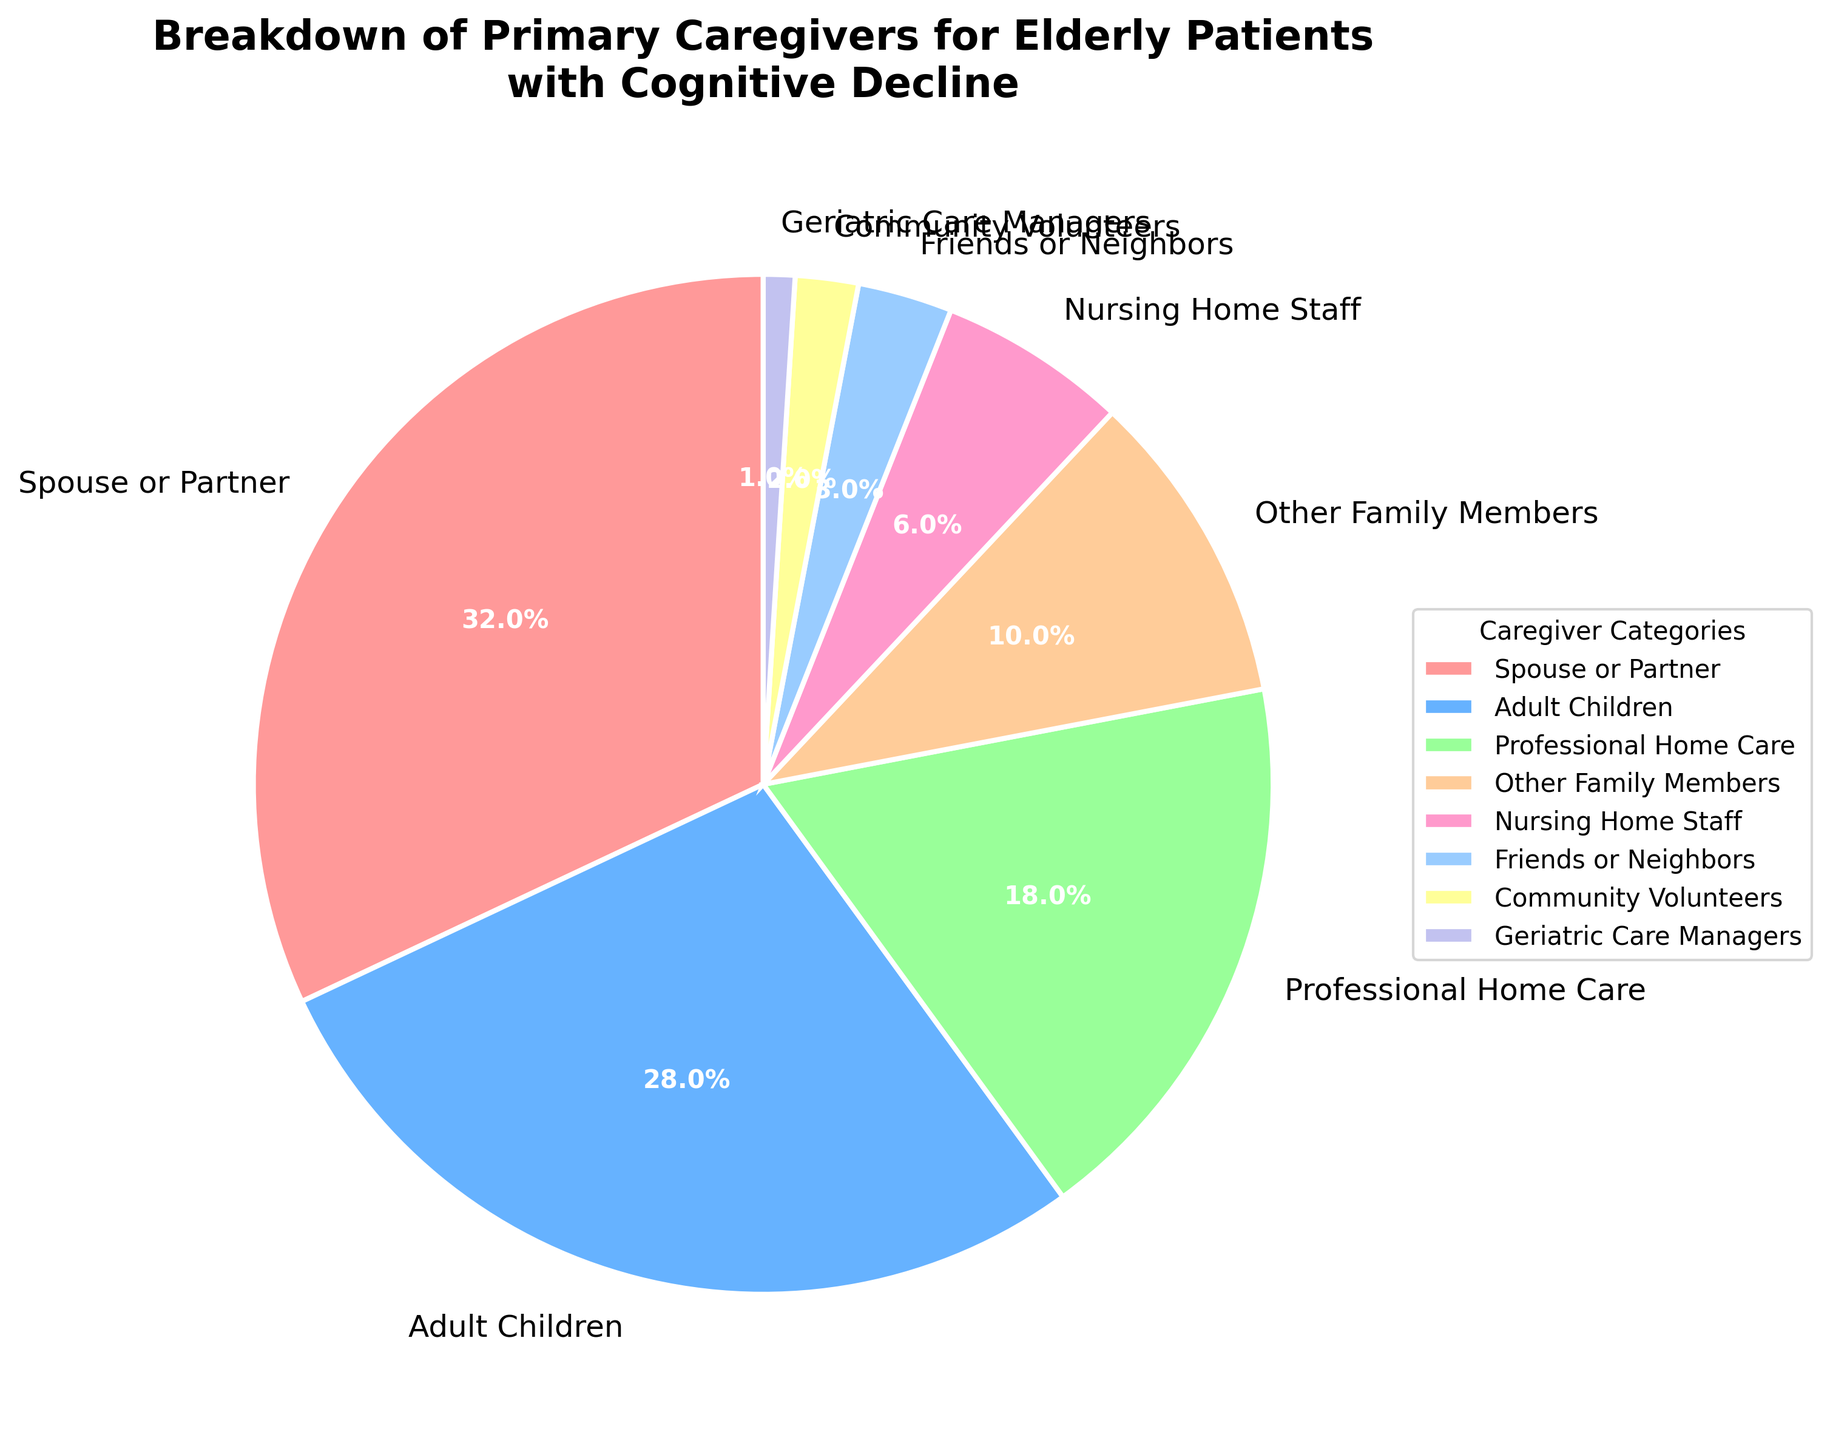What is the category with the highest percentage of primary caregivers? The pie chart shows various categories with their respective percentages. The slice representing "Spouse or Partner" is the largest, with a percentage of 32%.
Answer: Spouse or Partner Which two categories together account for more than half of the primary caregivers? By adding the percentages of the first two highest categories: Spouse or Partner (32%) and Adult Children (28%), the total is 32% + 28% = 60%, which is more than half.
Answer: Spouse or Partner and Adult Children How many categories make up less than 10% of the primary caregivers each? The pie chart shows that categories with less than 10% are Professional Home Care (18%), Other Family Members (10%), Nursing Home Staff (6%), Friends or Neighbors (3%), Community Volunteers (2%), and Geriatric Care Managers (1%). By counting these, there are 6 categories.
Answer: 6 What is the combined percentage of 'Nursing Home Staff' and 'Friends or Neighbors'? Adding the percentages of 'Nursing Home Staff' (6%) and 'Friends or Neighbors' (3%) results in 6% + 3% = 9%.
Answer: 9% Which categories make up less than 5% of the primary caregivers? By examining the pie chart, the categories with less than 5% are 'Friends or Neighbors' (3%), 'Community Volunteers' (2%), and 'Geriatric Care Managers' (1%).
Answer: Friends or Neighbors, Community Volunteers, Geriatric Care Managers Compared to 'Professional Home Care', what is the percentage difference with 'Spouse or Partner' as primary caregivers? The percentage for 'Spouse or Partner' is 32% and for 'Professional Home Care' is 18%. The difference is 32% - 18% = 14%.
Answer: 14% Which category is the smallest segment in the pie chart? The pie chart shows the smallest segment as 'Geriatric Care Managers' with a percentage of 1%.
Answer: Geriatric Care Managers What is the difference in percentage between 'Adult Children' and 'Other Family Members'? The percentage for 'Adult Children' is 28% and for 'Other Family Members' is 10%. The difference is 28% - 10% = 18%.
Answer: 18% How many percentage points greater is 'Spouse or Partner' than 'Geriatric Care Managers'? The percentage for 'Spouse or Partner' is 32% and for 'Geriatric Care Managers' is 1%. The difference in percentage is 32% - 1% = 31%.
Answer: 31% List the categories that have double-digit percentages. By looking at the pie chart, the categories with double-digit percentages are 'Spouse or Partner' (32%), 'Adult Children' (28%), 'Professional Home Care' (18%), and 'Other Family Members' (10%).
Answer: Spouse or Partner, Adult Children, Professional Home Care, Other Family Members 